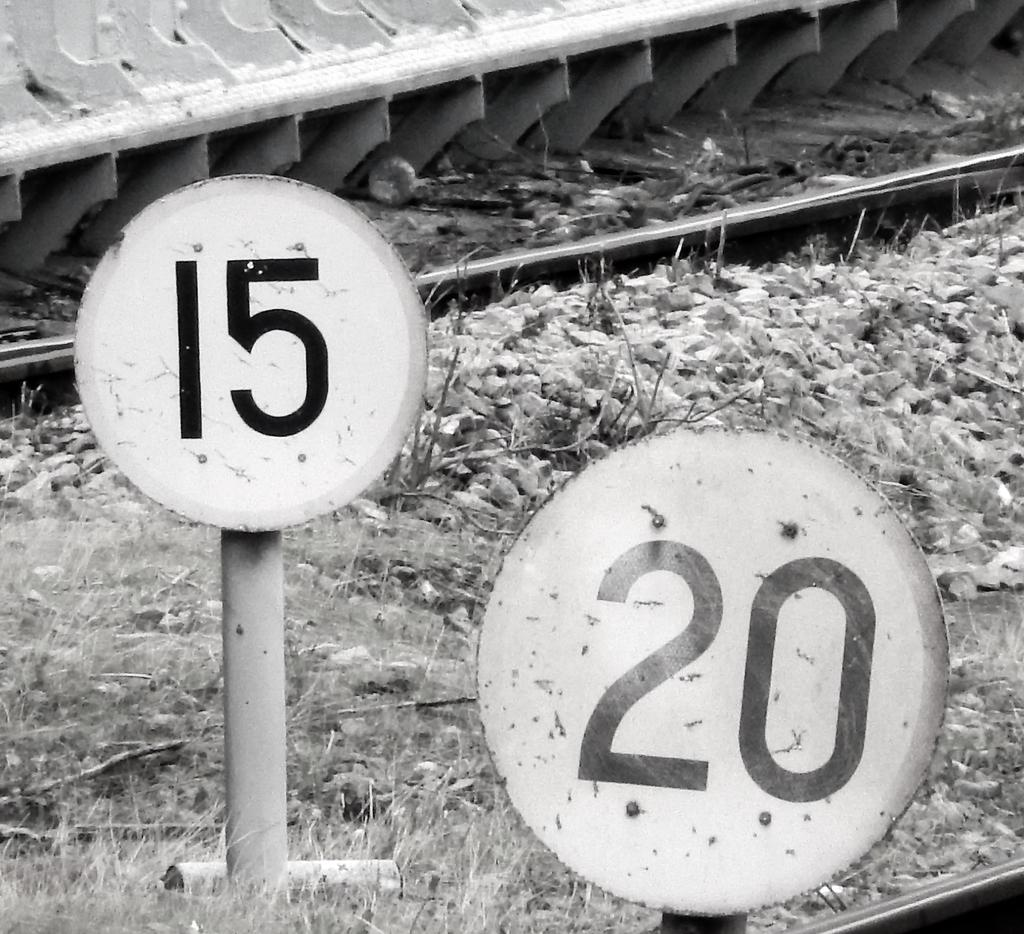<image>
Summarize the visual content of the image. Two signs in black and white, one reading 15 and one 20. 